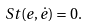Convert formula to latex. <formula><loc_0><loc_0><loc_500><loc_500>S t ( e , \dot { e } ) = 0 .</formula> 